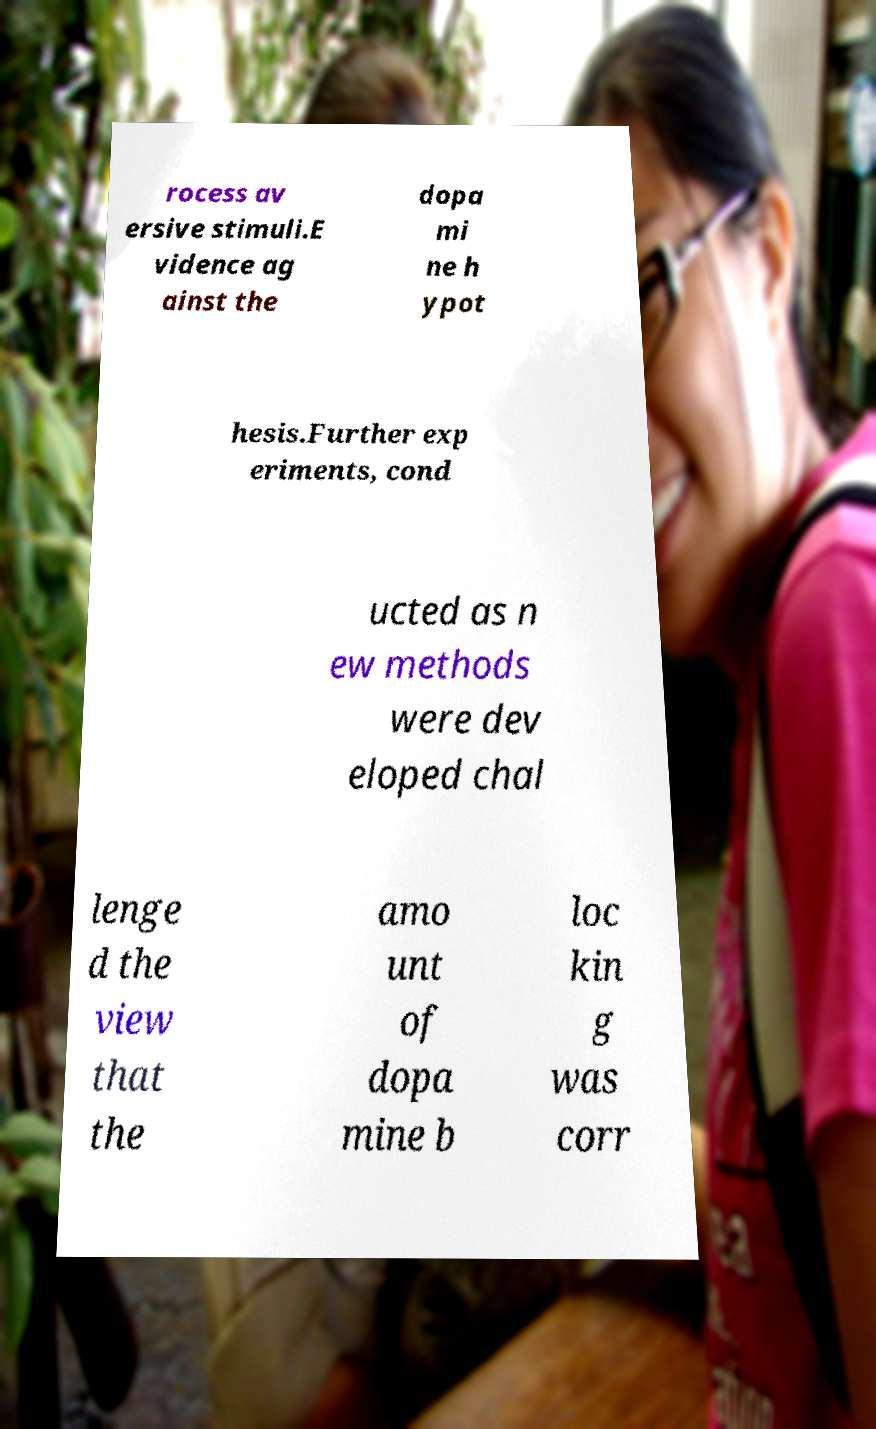Could you assist in decoding the text presented in this image and type it out clearly? rocess av ersive stimuli.E vidence ag ainst the dopa mi ne h ypot hesis.Further exp eriments, cond ucted as n ew methods were dev eloped chal lenge d the view that the amo unt of dopa mine b loc kin g was corr 